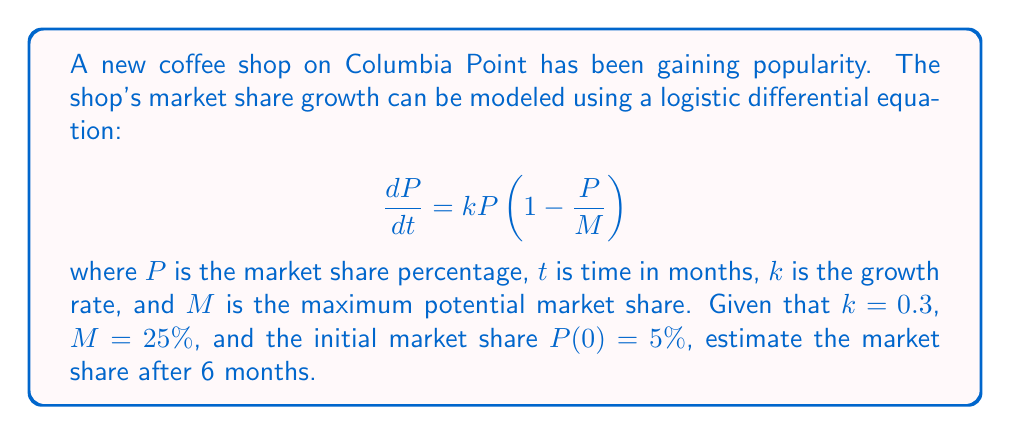What is the answer to this math problem? To solve this problem, we need to use the logistic growth model and its solution. The general solution to the logistic differential equation is:

$$P(t) = \frac{M}{1 + (\frac{M}{P_0} - 1)e^{-kt}}$$

Where $P_0$ is the initial market share.

Given information:
- $k = 0.3$ (growth rate)
- $M = 25\%$ (maximum potential market share)
- $P_0 = 5\%$ (initial market share)
- $t = 6$ months

Let's substitute these values into the equation:

$$P(6) = \frac{25}{1 + (\frac{25}{5} - 1)e^{-0.3(6)}}$$

Simplify:
$$P(6) = \frac{25}{1 + (5 - 1)e^{-1.8}}$$
$$P(6) = \frac{25}{1 + 4e^{-1.8}}$$

Now, let's calculate:
$e^{-1.8} \approx 0.1653$

Substituting this value:
$$P(6) = \frac{25}{1 + 4(0.1653)}$$
$$P(6) = \frac{25}{1 + 0.6612}$$
$$P(6) = \frac{25}{1.6612}$$
$$P(6) \approx 15.05$$

Therefore, the estimated market share after 6 months is approximately 15.05%.
Answer: 15.05% 